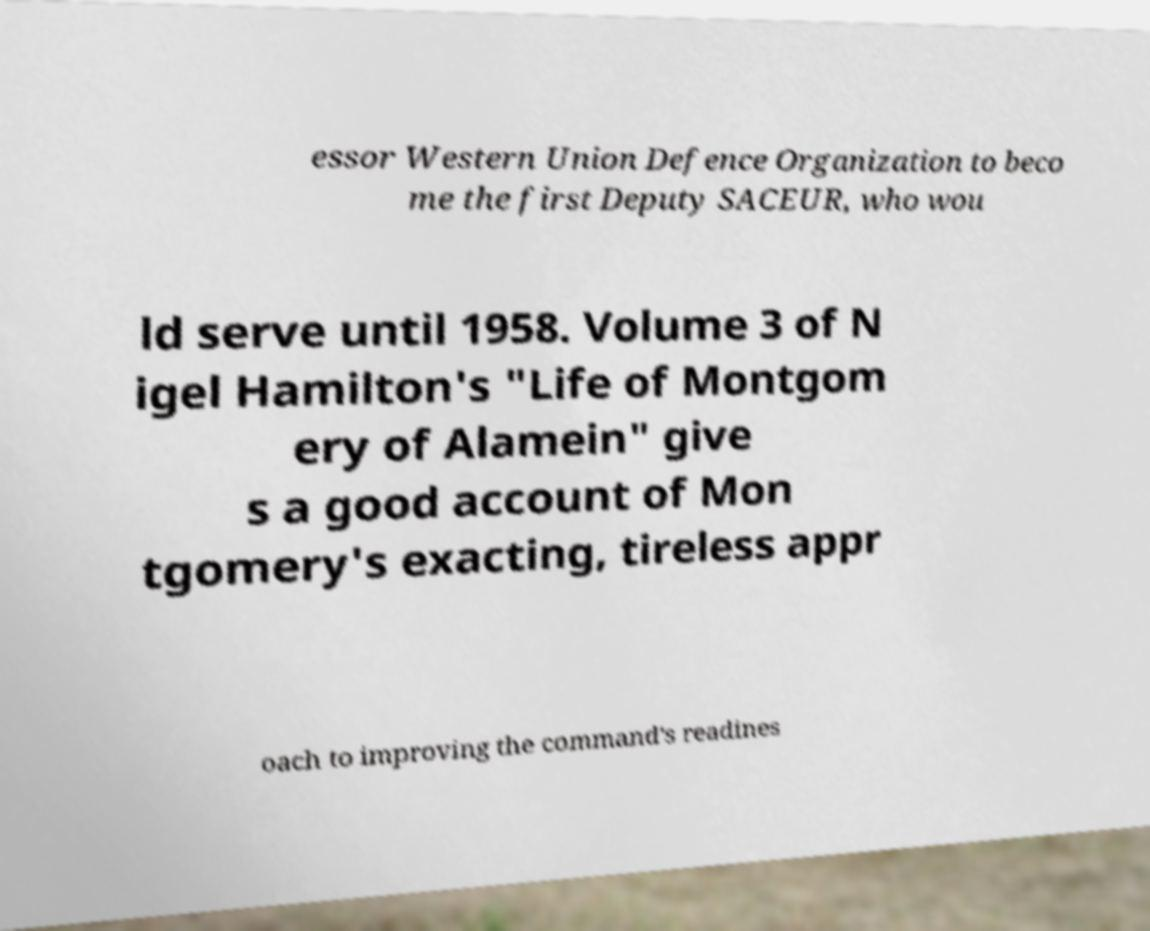Can you accurately transcribe the text from the provided image for me? essor Western Union Defence Organization to beco me the first Deputy SACEUR, who wou ld serve until 1958. Volume 3 of N igel Hamilton's "Life of Montgom ery of Alamein" give s a good account of Mon tgomery's exacting, tireless appr oach to improving the command's readines 